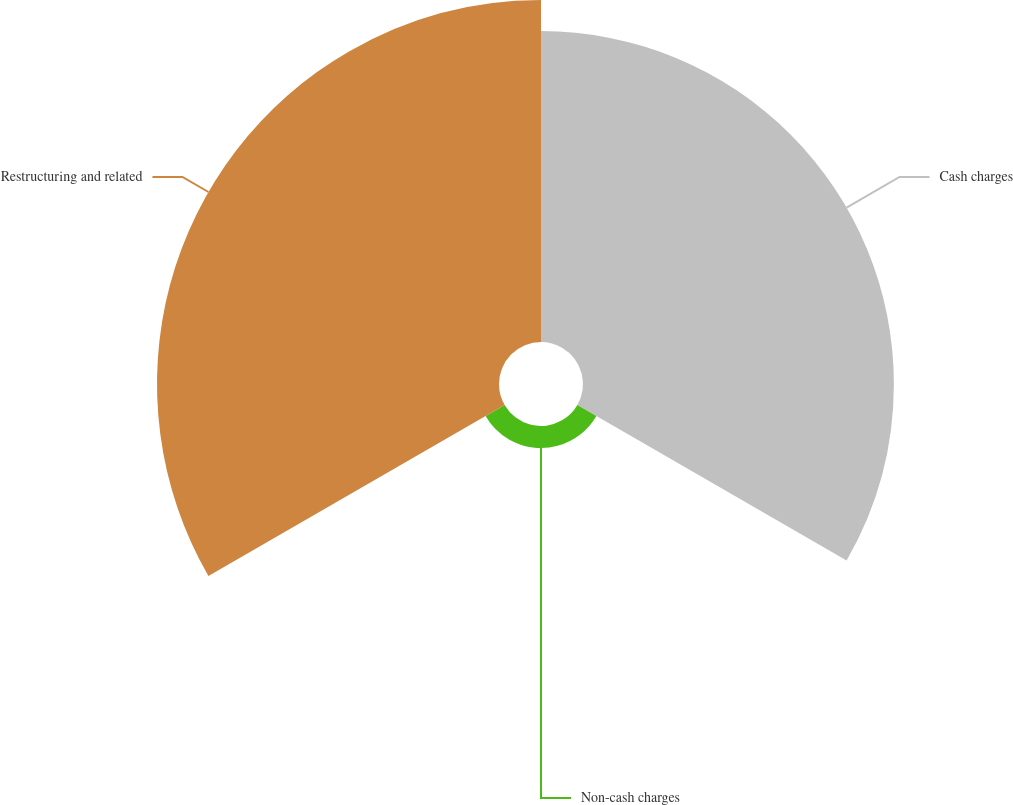<chart> <loc_0><loc_0><loc_500><loc_500><pie_chart><fcel>Cash charges<fcel>Non-cash charges<fcel>Restructuring and related<nl><fcel>46.06%<fcel>3.26%<fcel>50.67%<nl></chart> 